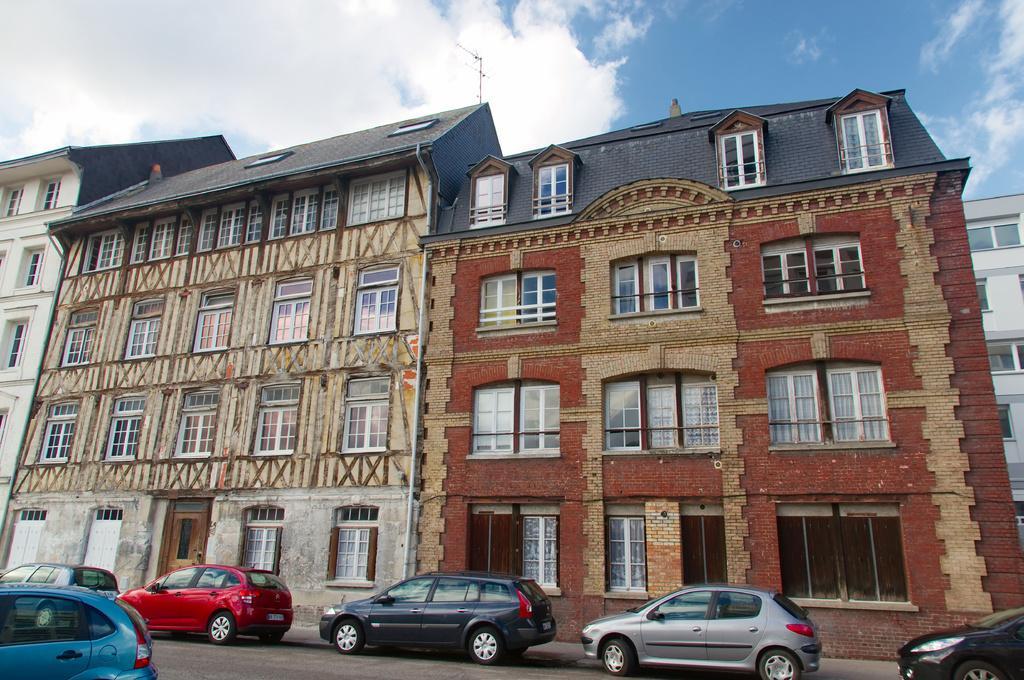Could you give a brief overview of what you see in this image? In this image we can see buildings, windows, vehicles on the road, we can see the sky with clouds. 